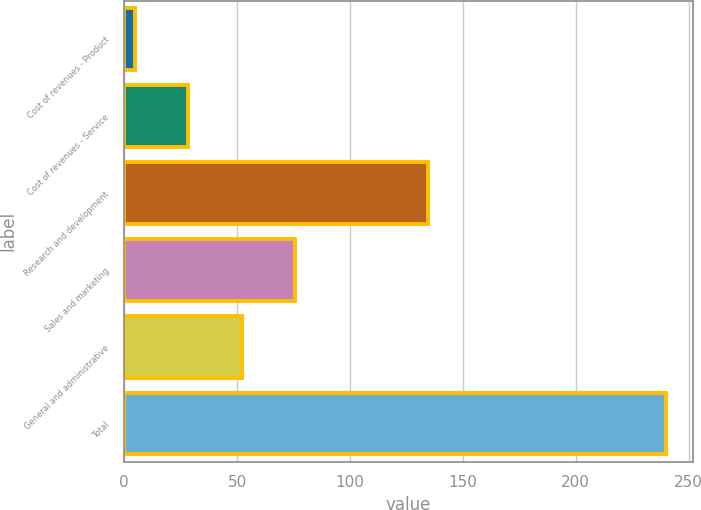Convert chart. <chart><loc_0><loc_0><loc_500><loc_500><bar_chart><fcel>Cost of revenues - Product<fcel>Cost of revenues - Service<fcel>Research and development<fcel>Sales and marketing<fcel>General and administrative<fcel>Total<nl><fcel>5<fcel>28.5<fcel>134.5<fcel>75.5<fcel>52<fcel>240<nl></chart> 